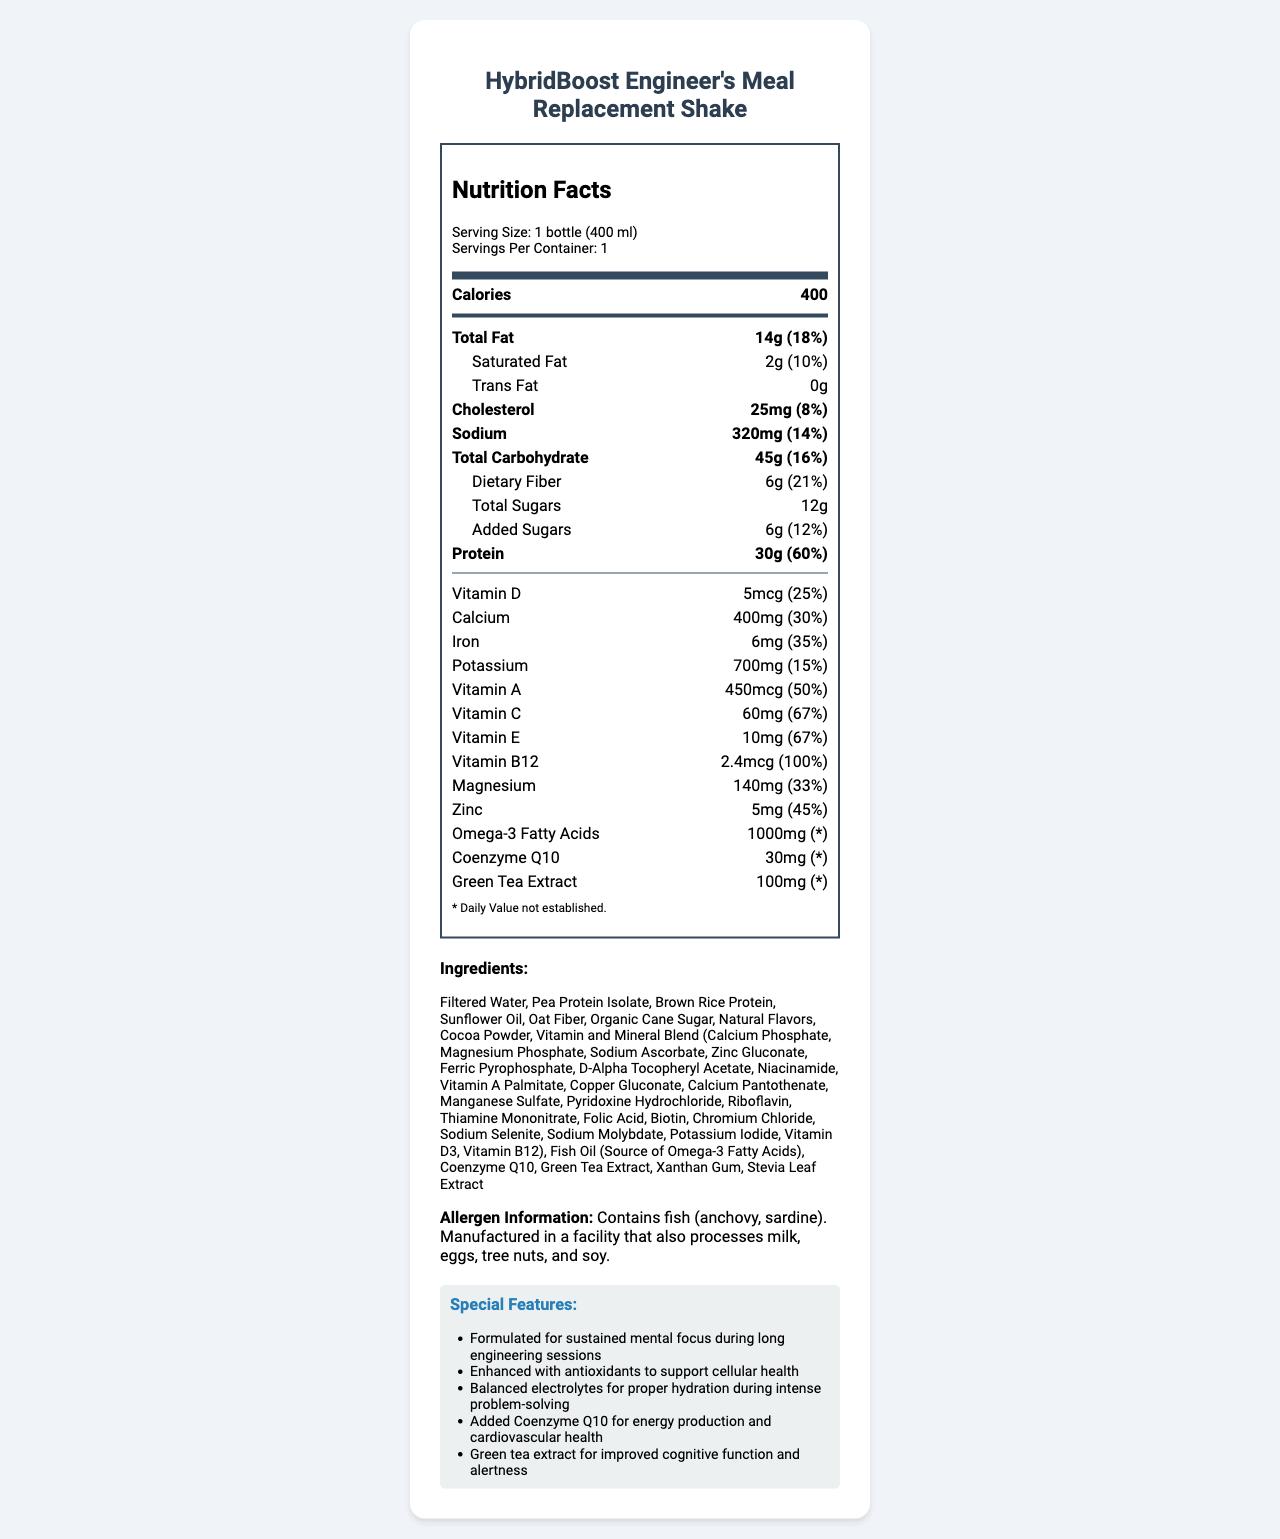what is the serving size of the HybridBoost Engineer's Meal Replacement Shake? The serving size is explicitly listed in the "Nutrition Facts" section under "Serving Size."
Answer: 1 bottle (400 ml) how many calories are in one serving of the meal replacement shake? The "Nutrition Facts" section shows "Calories: 400."
Answer: 400 calories what is the total amount of protein in the shake? The "Nutrition Facts" section lists "Protein: 30g."
Answer: 30g how much iron is in one serving of the shake, in terms of daily value percentage? The "Nutrition Facts" section shows "Iron: 6mg (35%)."
Answer: 35% is the shake suitable for vegetarians? The allergen information shows it contains fish (anchovy, sardine), making it unsuitable for vegetarians.
Answer: No which nutrient has the highest daily value percentage in the shake? A. Vitamin D B. Vitamin B12 C. Iron D. Zinc Vitamin B12 has a daily value of 100%, which is higher than the other listed nutrients in the options.
Answer: B. Vitamin B12 how much dietary fiber does the shake contain? The "Nutrition Facts" section lists "Dietary Fiber: 6g."
Answer: 6g which of the following special features is NOT mentioned as a benefit of the shake? A. Improved stamina B. Sustained mental focus C. Cellular health support D. Cognitive function improvement The "Special Features" section does not mention improved stamina.
Answer: A. Improved stamina is there any trans fat in the shake? The "Nutrition Facts" section shows "Trans Fat: 0g."
Answer: No summarize the main nutritional and special features of the HybridBoost Engineer's Meal Replacement Shake. The document provides a comprehensive overview of the nutritional content, including calories, macronutrients, vitamins, minerals, and special ingredients like omega-3 fatty acids, Coenzyme Q10, and green tea extract. It also lists several special features aimed at improving mental focus, cellular health, hydration, energy production, and cognitive function.
Answer: The HybridBoost Engineer's Meal Replacement Shake provides 400 calories per serving and is rich in nutrients, including 30g of protein, various essential vitamins, and minerals. It contains omega-3 acids, Coenzyme Q10, and green tea extract. Special features include sustained mental focus, antioxidant support, balanced electrolytes, energy production, and cognitive function improvement. what is the ingredient responsible for the omega-3 fatty acids in the shake? The ingredients list shows "Fish Oil (Source of Omega-3 Fatty Acids)."
Answer: Fish Oil how much-added sugar does the shake contain? The "Nutrition Facts" section shows "Added Sugars: 6g."
Answer: 6g does the shake contain any allergens like milk or soy? The "Allergen Information" section specifies the shake contains fish but is made in a facility that also processes other common allergens.
Answer: No, but it is manufactured in a facility that processes milk, eggs, tree nuts, and soy. how much magnesium does the shake provide as a percentage of daily value? The "Nutrition Facts" section shows "Magnesium: 140mg (33%)."
Answer: 33% can the exact omega3 fatty acids daily value percentage in the shake be determined from the document? The document states "* Daily Value not established" for omega-3 fatty acids, meaning it cannot be precisely determined from the provided information.
Answer: Not enough information 